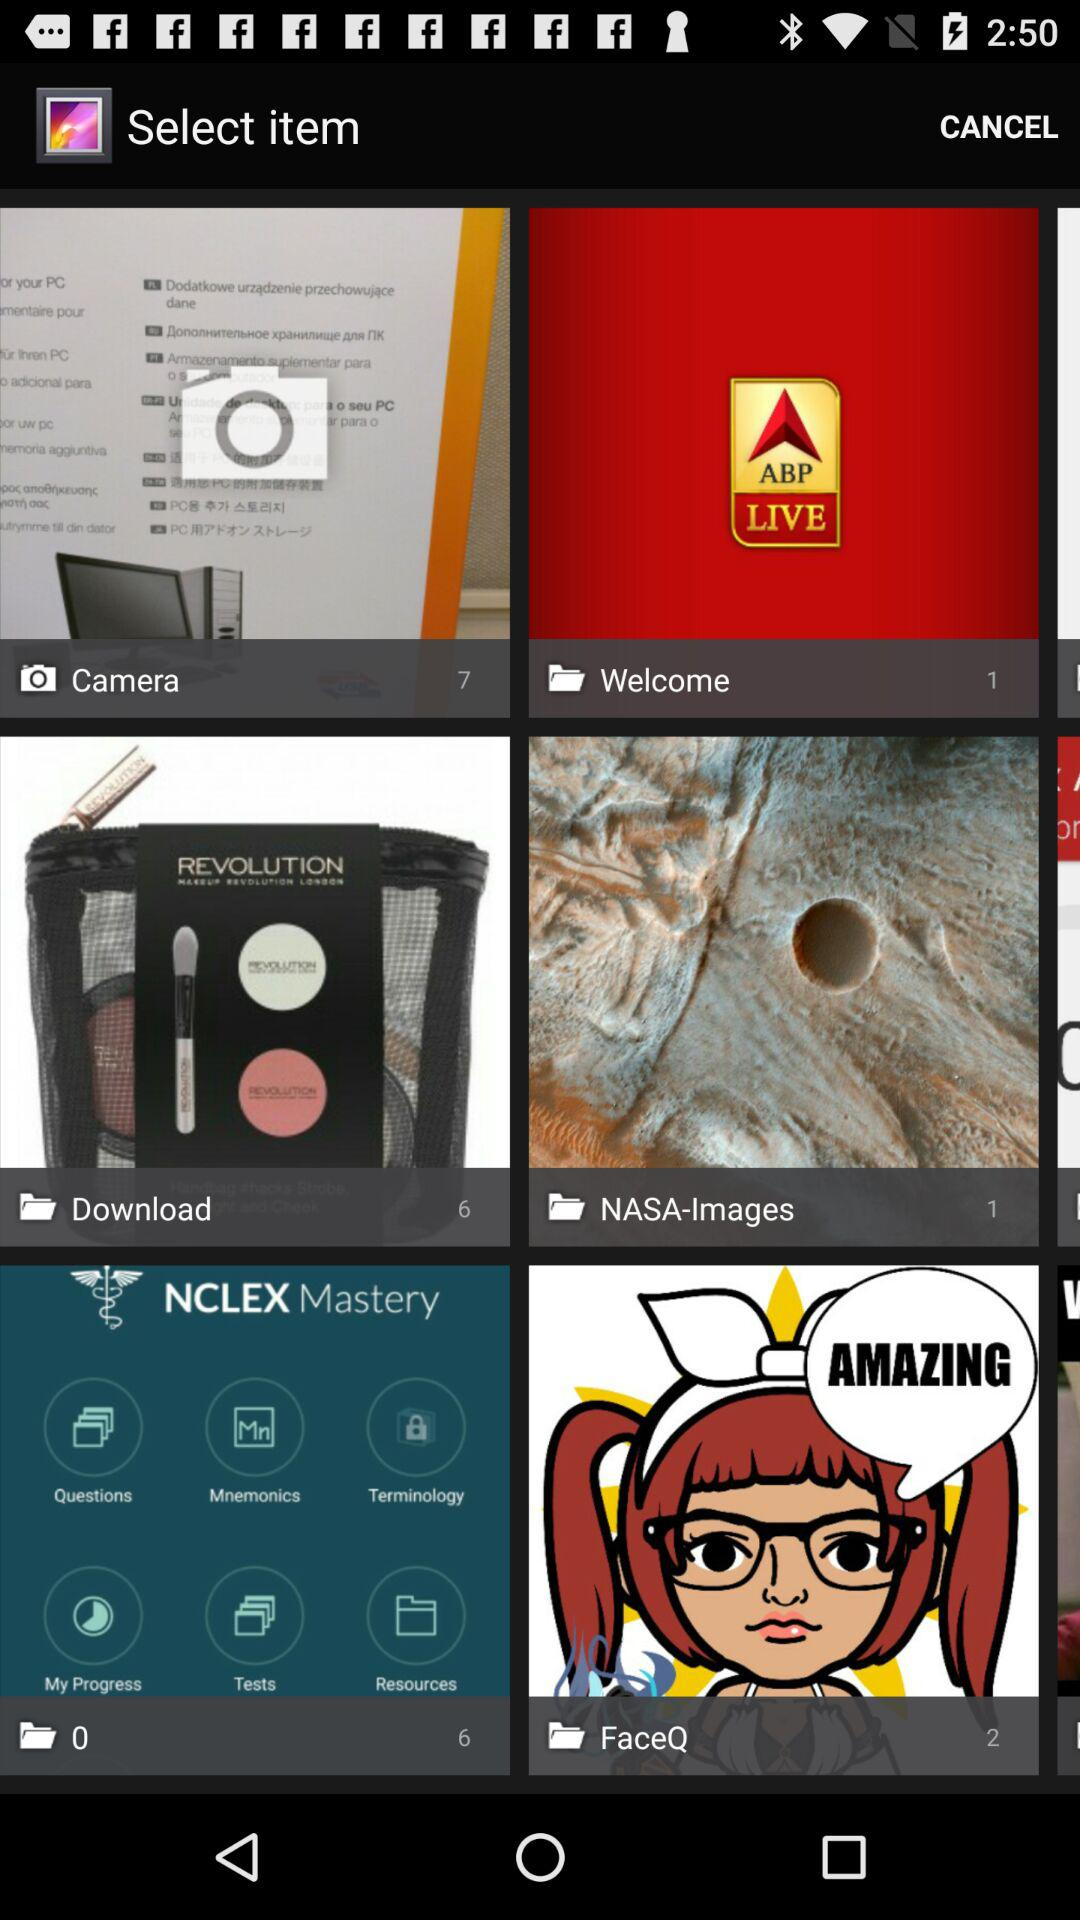How many items are in "Download"? There are 6 items in "Download". 